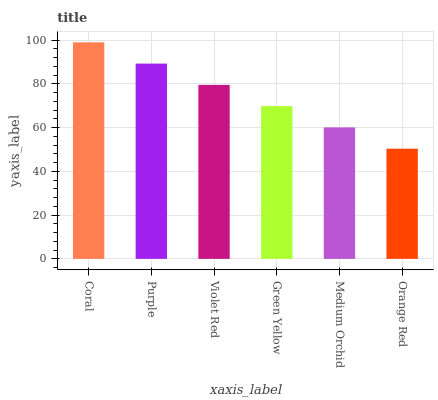Is Orange Red the minimum?
Answer yes or no. Yes. Is Coral the maximum?
Answer yes or no. Yes. Is Purple the minimum?
Answer yes or no. No. Is Purple the maximum?
Answer yes or no. No. Is Coral greater than Purple?
Answer yes or no. Yes. Is Purple less than Coral?
Answer yes or no. Yes. Is Purple greater than Coral?
Answer yes or no. No. Is Coral less than Purple?
Answer yes or no. No. Is Violet Red the high median?
Answer yes or no. Yes. Is Green Yellow the low median?
Answer yes or no. Yes. Is Purple the high median?
Answer yes or no. No. Is Violet Red the low median?
Answer yes or no. No. 